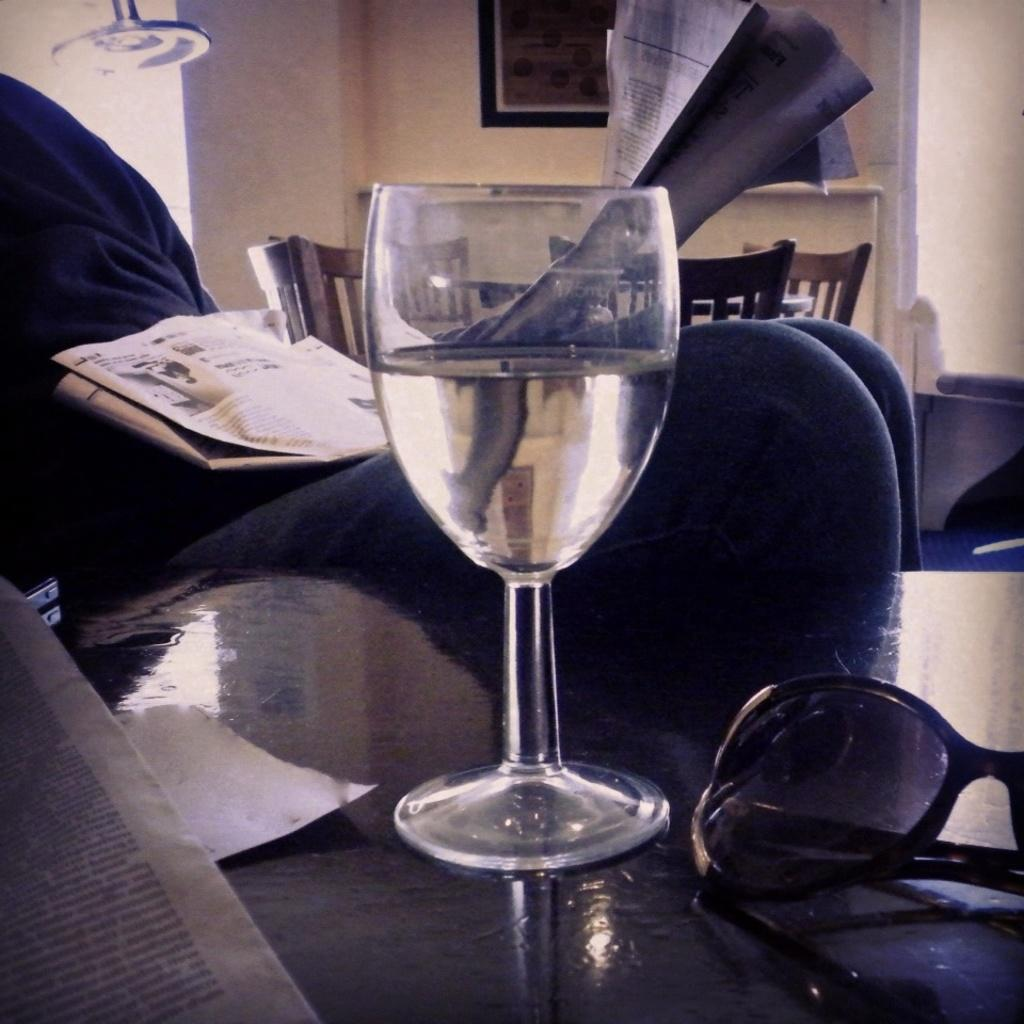What is present on the table in the image? There is a water glass in the image. Who or what is in front of the water glass? There is a person sitting in front of the water glass. What can be seen on the wall in the background of the image? There is a board attached to the wall in the background of the image. What type of knot is being tied by the person in the image? There is no knot-tying activity depicted in the image; the person is simply sitting in front of the water glass. 